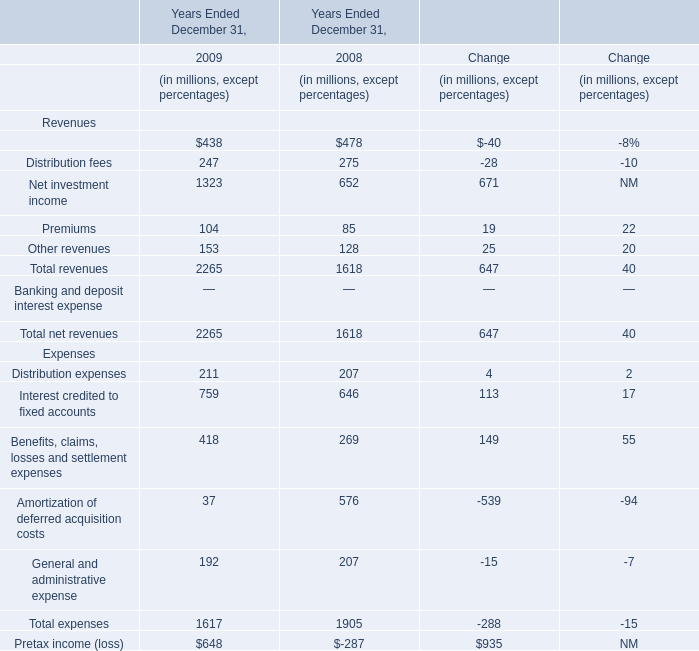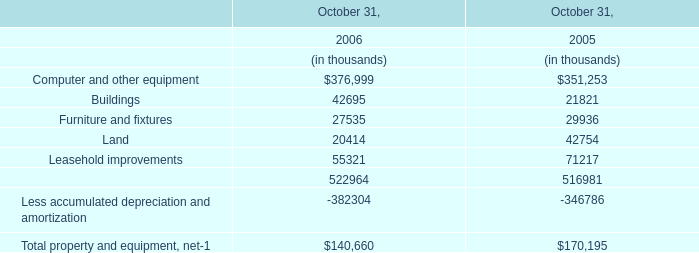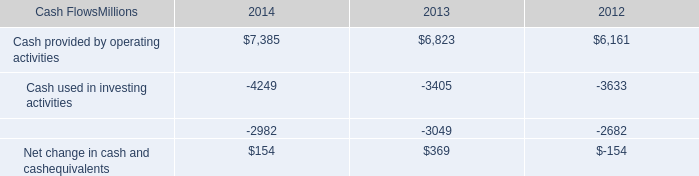What's the total amount of revenues in the range of 100 and 1000 in 2008? (in millions) 
Computations: (((478 + 275) + 652) + 128)
Answer: 1533.0. 